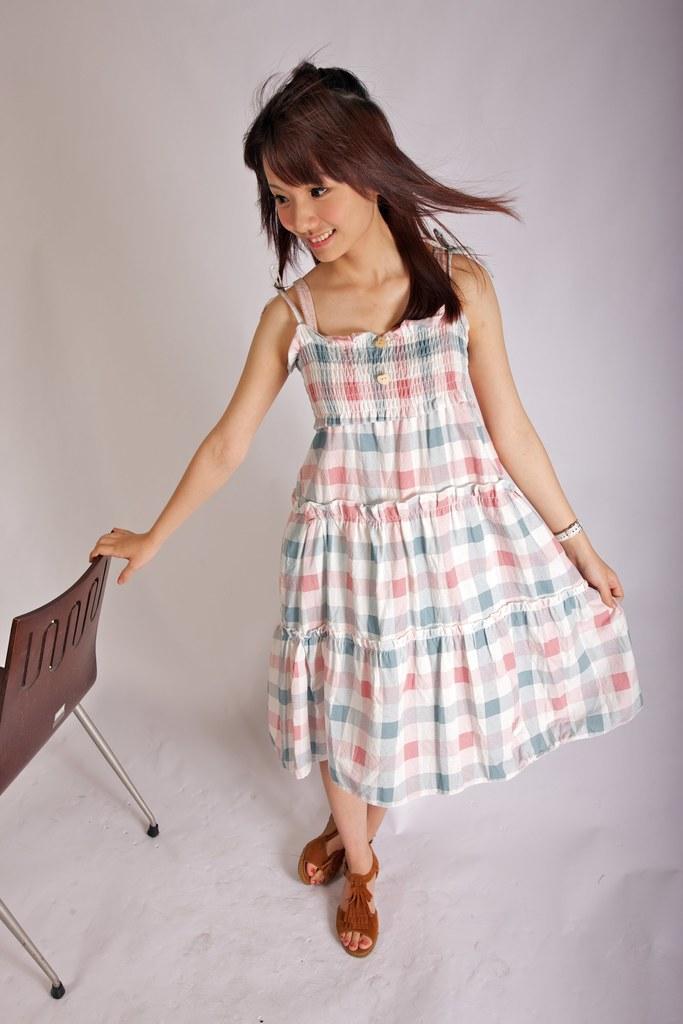Can you describe this image briefly? In this picture we can see women wore light color clothes, she is smiling and she is catching the chair. 